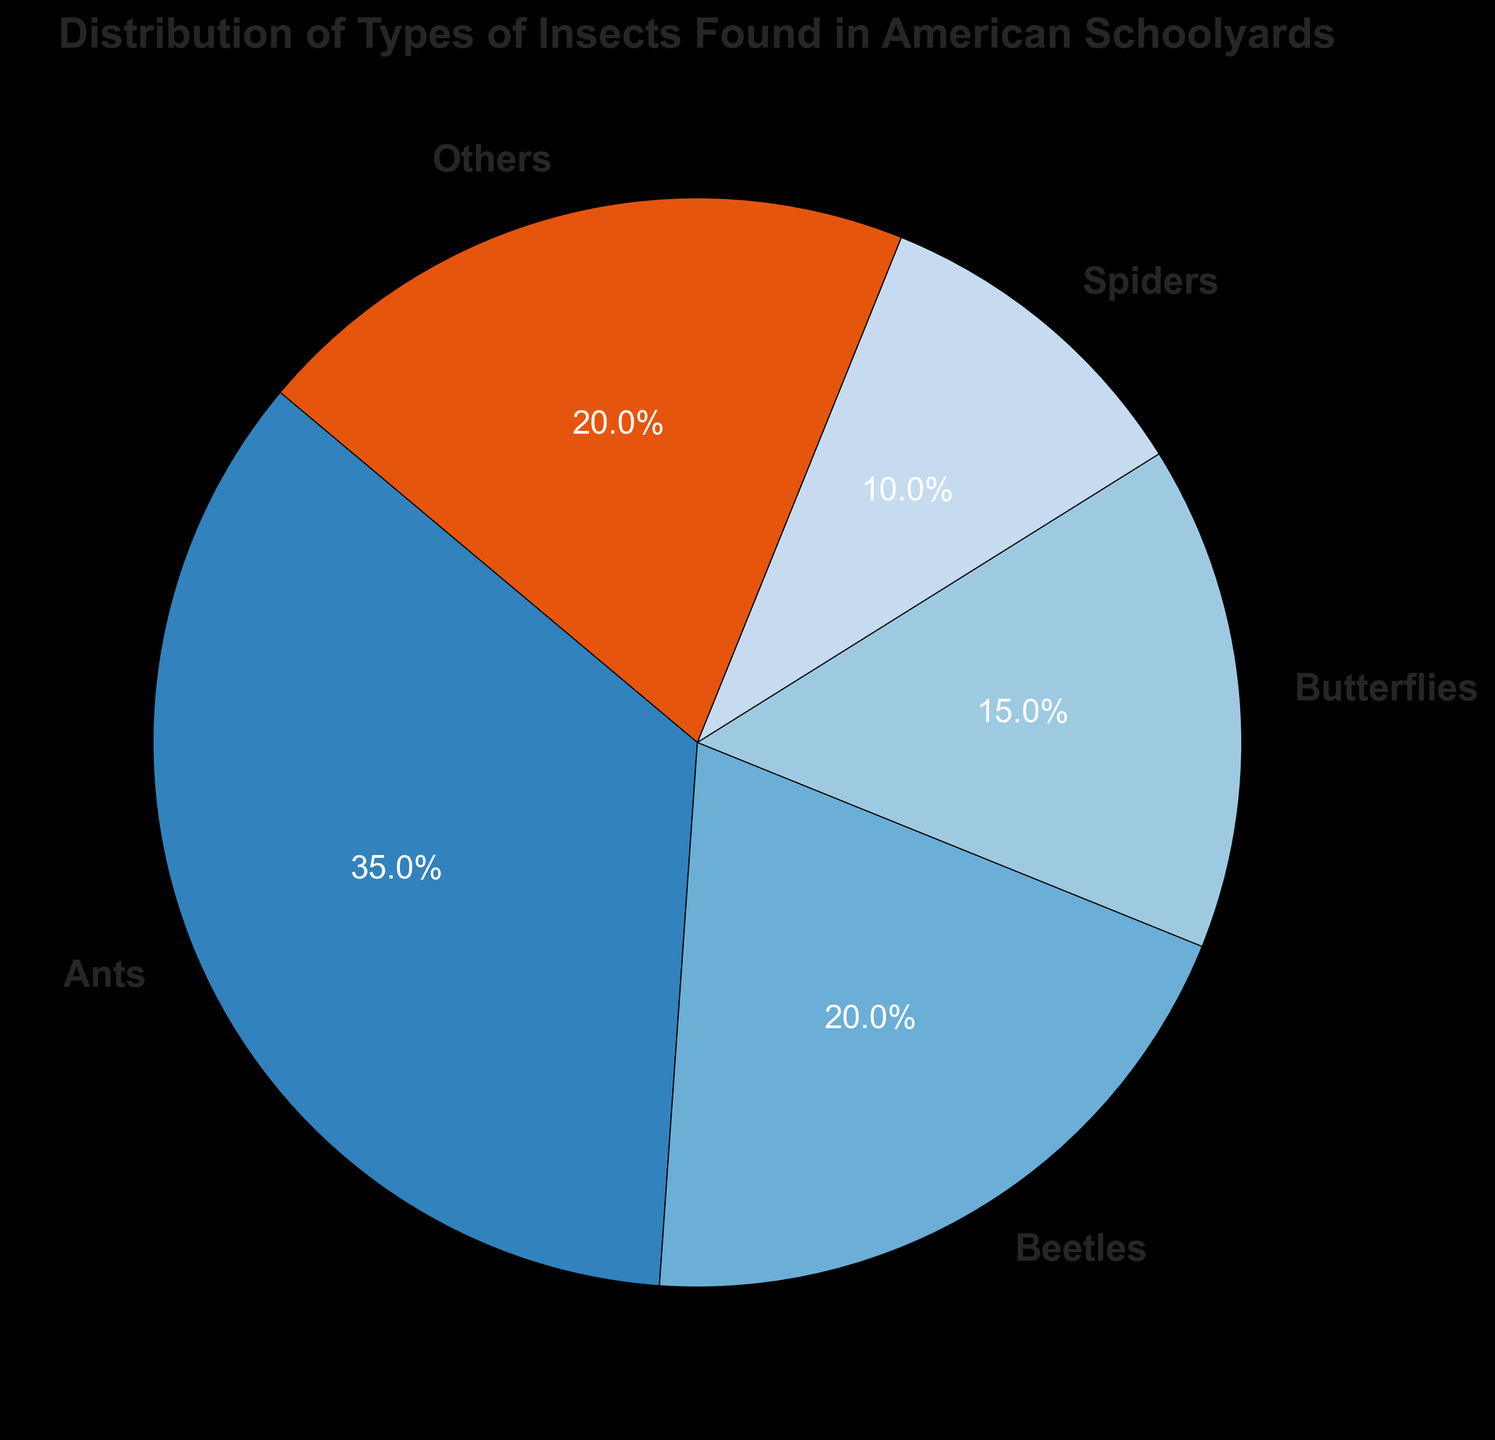What percentage of insects found in American schoolyards are ants? First, locate the segment labeled "Ants" in the pie chart. Then, read the percentage value written on or near the segment.
Answer: 35% Which type of insect is found the least frequently in American schoolyards? Identify the segment in the pie chart with the smallest percentage value. The label on this segment indicates the type of insect.
Answer: Spiders What is the combined percentage of beetles and butterflies? Locate the segments for "Beetles" and "Butterflies" in the pie chart. Add their respective percentages: 20% (Beetles) + 15% (Butterflies).
Answer: 35% How many more ants are there compared to spiders, as a percentage? Locate the percentages for "Ants" and "Spiders" in the pie chart. Subtract the smaller percentage from the larger one: 35% (Ants) - 10% (Spiders).
Answer: 25% Are butterflies more or less common than beetles, and by what percentage point difference? Locate the segments for "Butterflies" and "Beetles" in the pie chart. Subtract the smaller percentage from the larger one: 20% (Beetles) - 15% (Butterflies).
Answer: Less common by 5% Which types of insects occupy an equal percentage in the schoolyards? Identify the segments that have the same percentage value. Confirm this by comparing the labels and percentages.
Answer: Beetles and Others What is the average percentage of ants, spiders, and butterflies together? Add the percentages of "Ants", "Spiders", and "Butterflies", then divide by the number of types (3). Calculation: (35% + 10% + 15%) / 3.
Answer: 20% How does the distribution of spiders compare to the combined distribution of butterflies and others? Calculate the sum of the percentages for "Butterflies" and "Others": 15% (Butterflies) + 20% (Others) = 35%. Compare this to the percentage for "Spiders" (10%).
Answer: 25% more Which color represents the segment for ants in the pie chart and what is its significance in relation to other segments? Analyze the colors used in the pie chart to identify the segment for "Ants". Note the corresponding color and compare it with the colors of other segments to see if it stands out or blends in.
Answer: The specific color varies (context needed), but the segment should be easy to locate due to its larger proportion 